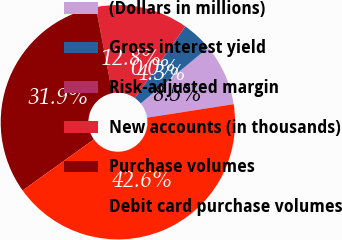<chart> <loc_0><loc_0><loc_500><loc_500><pie_chart><fcel>(Dollars in millions)<fcel>Gross interest yield<fcel>Risk-adjusted margin<fcel>New accounts (in thousands)<fcel>Purchase volumes<fcel>Debit card purchase volumes<nl><fcel>8.52%<fcel>4.26%<fcel>0.0%<fcel>12.77%<fcel>31.88%<fcel>42.57%<nl></chart> 